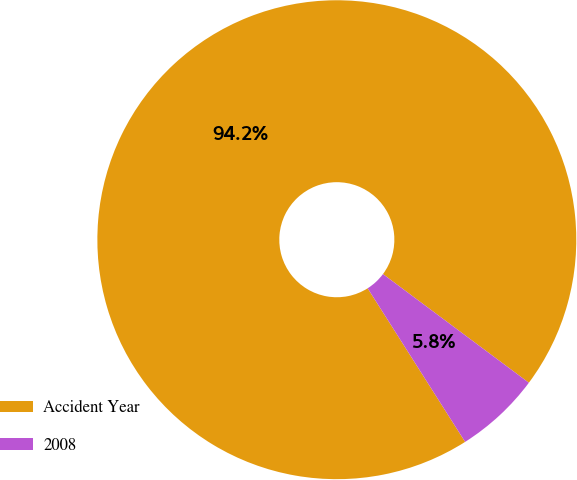Convert chart. <chart><loc_0><loc_0><loc_500><loc_500><pie_chart><fcel>Accident Year<fcel>2008<nl><fcel>94.19%<fcel>5.81%<nl></chart> 